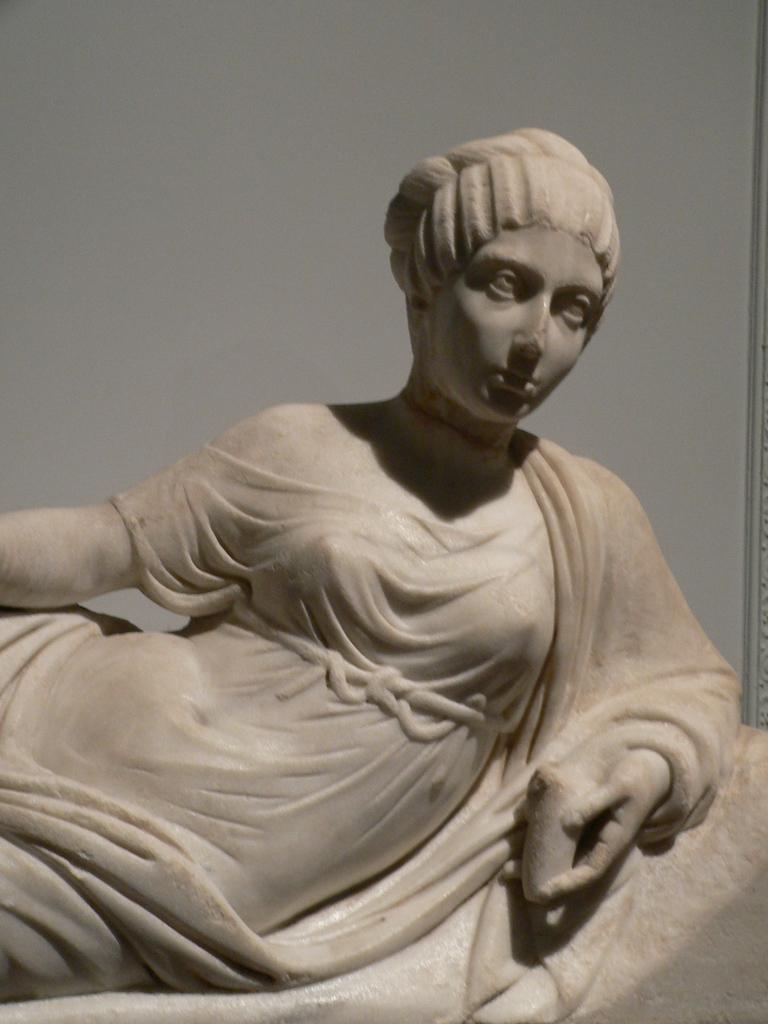Could you give a brief overview of what you see in this image? This image is taken indoors. In the background there is a wall. In the middle of the image there is a sculpture of a woman. 